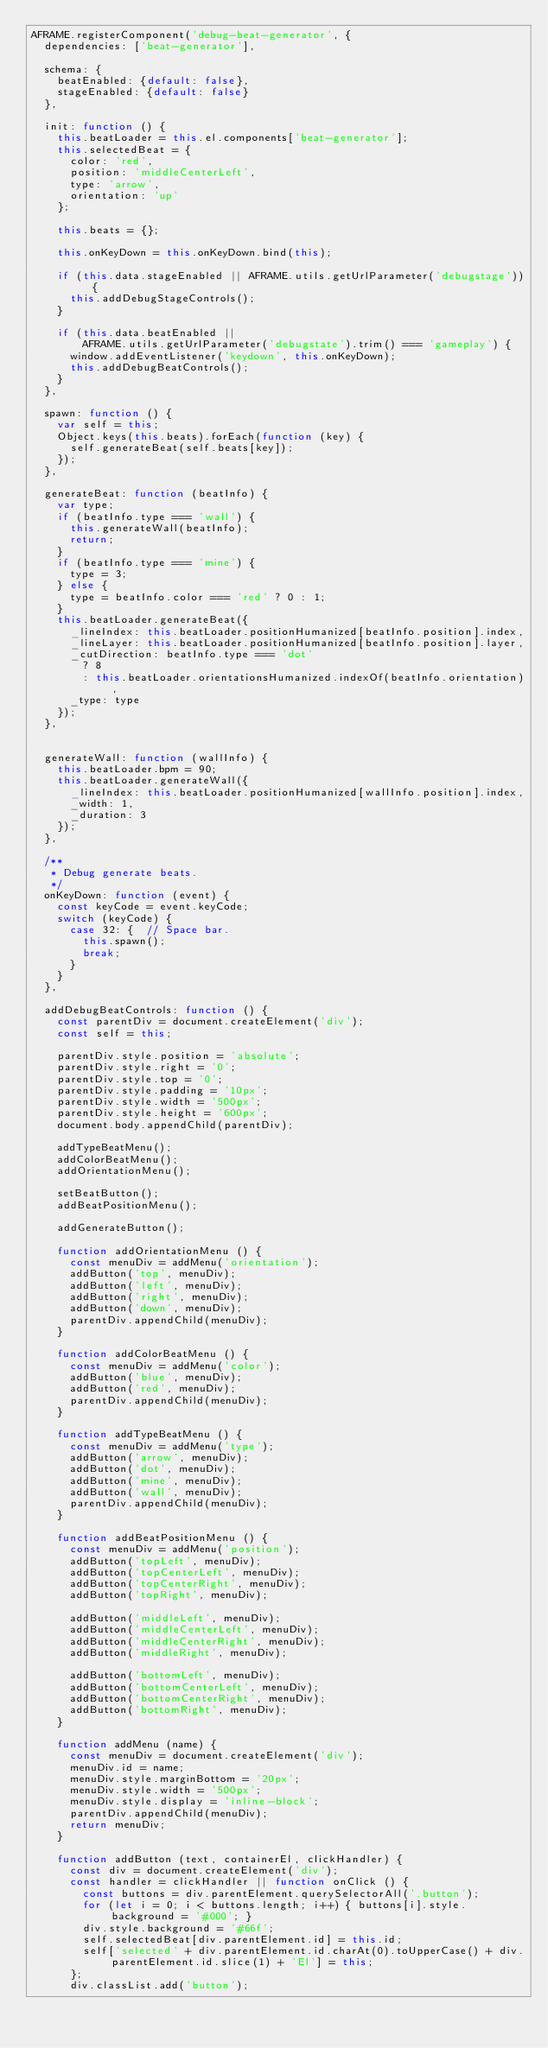<code> <loc_0><loc_0><loc_500><loc_500><_JavaScript_>AFRAME.registerComponent('debug-beat-generator', {
  dependencies: ['beat-generator'],

  schema: {
    beatEnabled: {default: false},
    stageEnabled: {default: false}
  },

  init: function () {
    this.beatLoader = this.el.components['beat-generator'];
    this.selectedBeat = {
      color: 'red',
      position: 'middleCenterLeft',
      type: 'arrow',
      orientation: 'up'
    };

    this.beats = {};

    this.onKeyDown = this.onKeyDown.bind(this);

    if (this.data.stageEnabled || AFRAME.utils.getUrlParameter('debugstage')) {
      this.addDebugStageControls();
    }

    if (this.data.beatEnabled ||
        AFRAME.utils.getUrlParameter('debugstate').trim() === 'gameplay') {
      window.addEventListener('keydown', this.onKeyDown);
      this.addDebugBeatControls();
    }
  },

  spawn: function () {
    var self = this;
    Object.keys(this.beats).forEach(function (key) {
      self.generateBeat(self.beats[key]);
    });
  },

  generateBeat: function (beatInfo) {
    var type;
    if (beatInfo.type === 'wall') {
      this.generateWall(beatInfo);
      return;
    }
    if (beatInfo.type === 'mine') {
      type = 3;
    } else {
      type = beatInfo.color === 'red' ? 0 : 1;
    }
    this.beatLoader.generateBeat({
      _lineIndex: this.beatLoader.positionHumanized[beatInfo.position].index,
      _lineLayer: this.beatLoader.positionHumanized[beatInfo.position].layer,
      _cutDirection: beatInfo.type === 'dot'
        ? 8
        : this.beatLoader.orientationsHumanized.indexOf(beatInfo.orientation),
      _type: type
    });
  },


  generateWall: function (wallInfo) {
    this.beatLoader.bpm = 90;
    this.beatLoader.generateWall({
      _lineIndex: this.beatLoader.positionHumanized[wallInfo.position].index,
      _width: 1,
      _duration: 3
    });
  },

  /**
   * Debug generate beats.
   */
  onKeyDown: function (event) {
    const keyCode = event.keyCode;
    switch (keyCode) {
      case 32: {  // Space bar.
        this.spawn();
        break;
      }
    }
  },

  addDebugBeatControls: function () {
    const parentDiv = document.createElement('div');
    const self = this;

    parentDiv.style.position = 'absolute';
    parentDiv.style.right = '0';
    parentDiv.style.top = '0';
    parentDiv.style.padding = '10px';
    parentDiv.style.width = '500px';
    parentDiv.style.height = '600px';
    document.body.appendChild(parentDiv);

    addTypeBeatMenu();
    addColorBeatMenu();
    addOrientationMenu();

    setBeatButton();
    addBeatPositionMenu();

    addGenerateButton();

    function addOrientationMenu () {
      const menuDiv = addMenu('orientation');
      addButton('top', menuDiv);
      addButton('left', menuDiv);
      addButton('right', menuDiv);
      addButton('down', menuDiv);
      parentDiv.appendChild(menuDiv);
    }

    function addColorBeatMenu () {
      const menuDiv = addMenu('color');
      addButton('blue', menuDiv);
      addButton('red', menuDiv);
      parentDiv.appendChild(menuDiv);
    }

    function addTypeBeatMenu () {
      const menuDiv = addMenu('type');
      addButton('arrow', menuDiv);
      addButton('dot', menuDiv);
      addButton('mine', menuDiv);
      addButton('wall', menuDiv);
      parentDiv.appendChild(menuDiv);
    }

    function addBeatPositionMenu () {
      const menuDiv = addMenu('position');
      addButton('topLeft', menuDiv);
      addButton('topCenterLeft', menuDiv);
      addButton('topCenterRight', menuDiv);
      addButton('topRight', menuDiv);

      addButton('middleLeft', menuDiv);
      addButton('middleCenterLeft', menuDiv);
      addButton('middleCenterRight', menuDiv);
      addButton('middleRight', menuDiv);

      addButton('bottomLeft', menuDiv);
      addButton('bottomCenterLeft', menuDiv);
      addButton('bottomCenterRight', menuDiv);
      addButton('bottomRight', menuDiv);
    }

    function addMenu (name) {
      const menuDiv = document.createElement('div');
      menuDiv.id = name;
      menuDiv.style.marginBottom = '20px';
      menuDiv.style.width = '500px';
      menuDiv.style.display = 'inline-block';
      parentDiv.appendChild(menuDiv);
      return menuDiv;
    }

    function addButton (text, containerEl, clickHandler) {
      const div = document.createElement('div');
      const handler = clickHandler || function onClick () {
        const buttons = div.parentElement.querySelectorAll('.button');
        for (let i = 0; i < buttons.length; i++) { buttons[i].style.background = '#000'; }
        div.style.background = '#66f';
        self.selectedBeat[div.parentElement.id] = this.id;
        self['selected' + div.parentElement.id.charAt(0).toUpperCase() + div.parentElement.id.slice(1) + 'El'] = this;
      };
      div.classList.add('button');</code> 